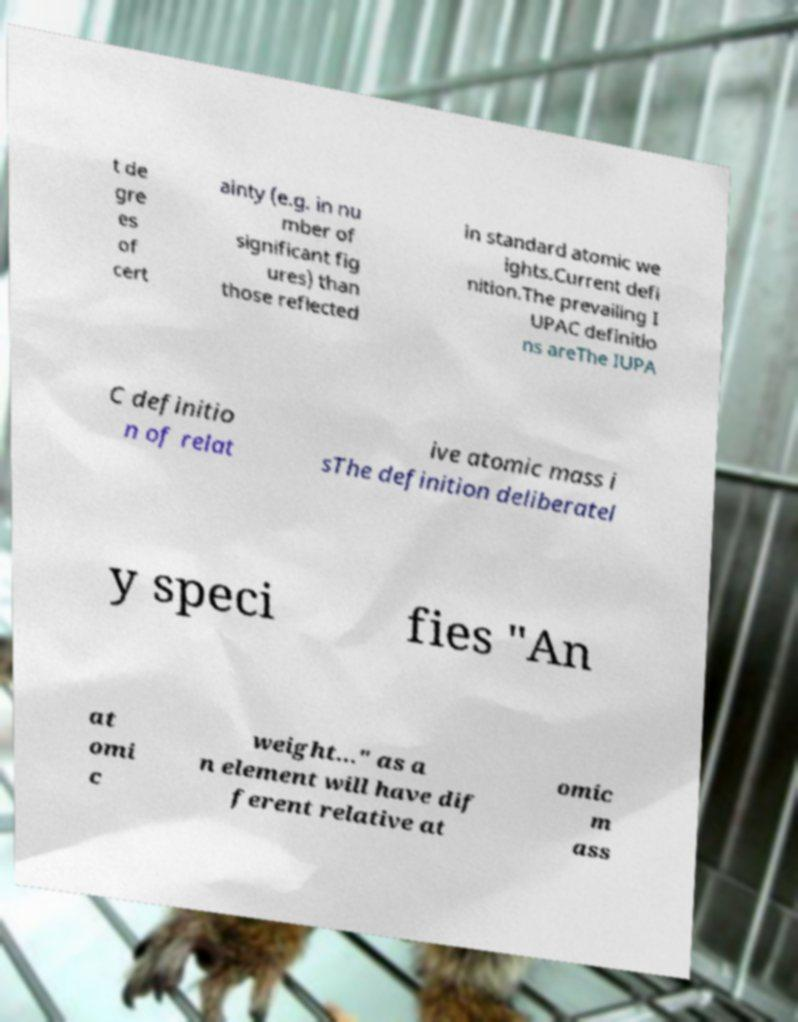I need the written content from this picture converted into text. Can you do that? t de gre es of cert ainty (e.g. in nu mber of significant fig ures) than those reflected in standard atomic we ights.Current defi nition.The prevailing I UPAC definitio ns areThe IUPA C definitio n of relat ive atomic mass i sThe definition deliberatel y speci fies "An at omi c weight…" as a n element will have dif ferent relative at omic m ass 